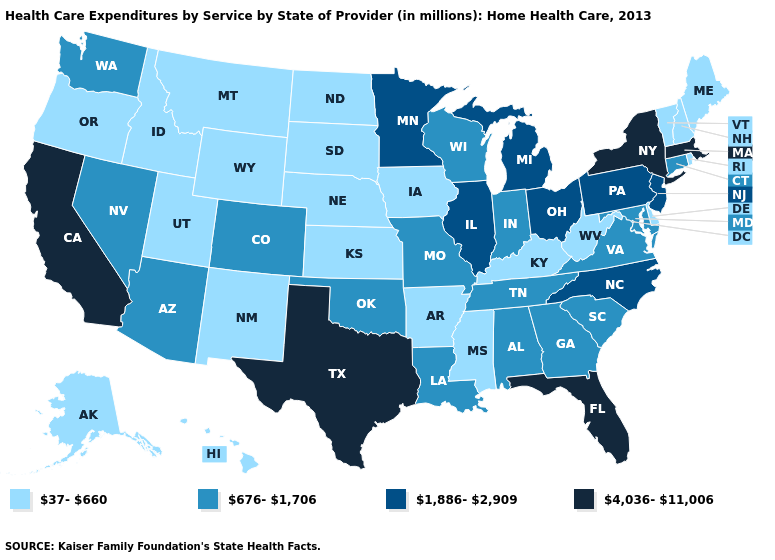Name the states that have a value in the range 37-660?
Write a very short answer. Alaska, Arkansas, Delaware, Hawaii, Idaho, Iowa, Kansas, Kentucky, Maine, Mississippi, Montana, Nebraska, New Hampshire, New Mexico, North Dakota, Oregon, Rhode Island, South Dakota, Utah, Vermont, West Virginia, Wyoming. Does the map have missing data?
Answer briefly. No. Does Idaho have the lowest value in the West?
Keep it brief. Yes. Which states have the lowest value in the USA?
Concise answer only. Alaska, Arkansas, Delaware, Hawaii, Idaho, Iowa, Kansas, Kentucky, Maine, Mississippi, Montana, Nebraska, New Hampshire, New Mexico, North Dakota, Oregon, Rhode Island, South Dakota, Utah, Vermont, West Virginia, Wyoming. What is the lowest value in states that border Missouri?
Short answer required. 37-660. Name the states that have a value in the range 4,036-11,006?
Quick response, please. California, Florida, Massachusetts, New York, Texas. What is the lowest value in the USA?
Give a very brief answer. 37-660. What is the value of Iowa?
Keep it brief. 37-660. Does Maine have the highest value in the USA?
Give a very brief answer. No. Does Vermont have the same value as Montana?
Give a very brief answer. Yes. Name the states that have a value in the range 676-1,706?
Answer briefly. Alabama, Arizona, Colorado, Connecticut, Georgia, Indiana, Louisiana, Maryland, Missouri, Nevada, Oklahoma, South Carolina, Tennessee, Virginia, Washington, Wisconsin. Does the map have missing data?
Keep it brief. No. Is the legend a continuous bar?
Keep it brief. No. Is the legend a continuous bar?
Concise answer only. No. Among the states that border Connecticut , which have the highest value?
Give a very brief answer. Massachusetts, New York. 